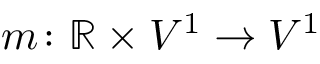<formula> <loc_0><loc_0><loc_500><loc_500>m \colon \mathbb { R } \times V ^ { 1 } \to V ^ { 1 }</formula> 